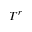<formula> <loc_0><loc_0><loc_500><loc_500>T ^ { r }</formula> 